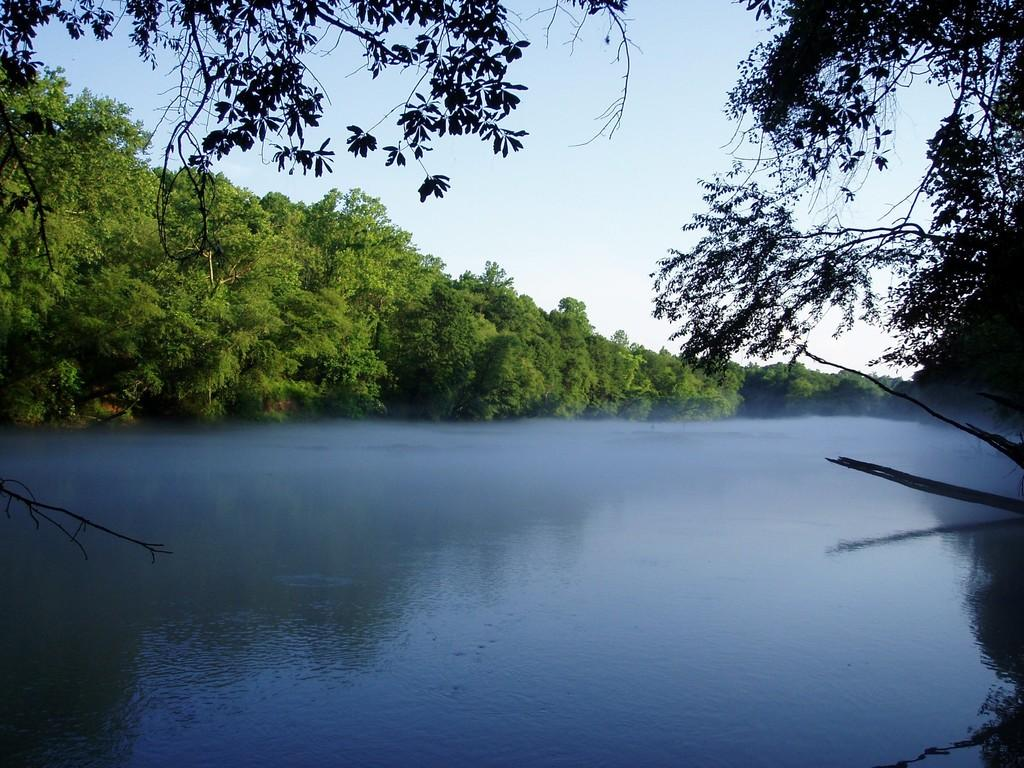What is visible in the image? Water, trees, and the sky are visible in the image. Can you describe the water in the image? The water is visible, but its specific characteristics are not mentioned in the facts. What is the background of the image? The sky is visible in the background of the image. What is the purpose of the war in the image? There is no mention of war in the image or the provided facts. What type of stew is being prepared in the image? There is no mention of stew or any cooking activity in the image or the provided facts. 